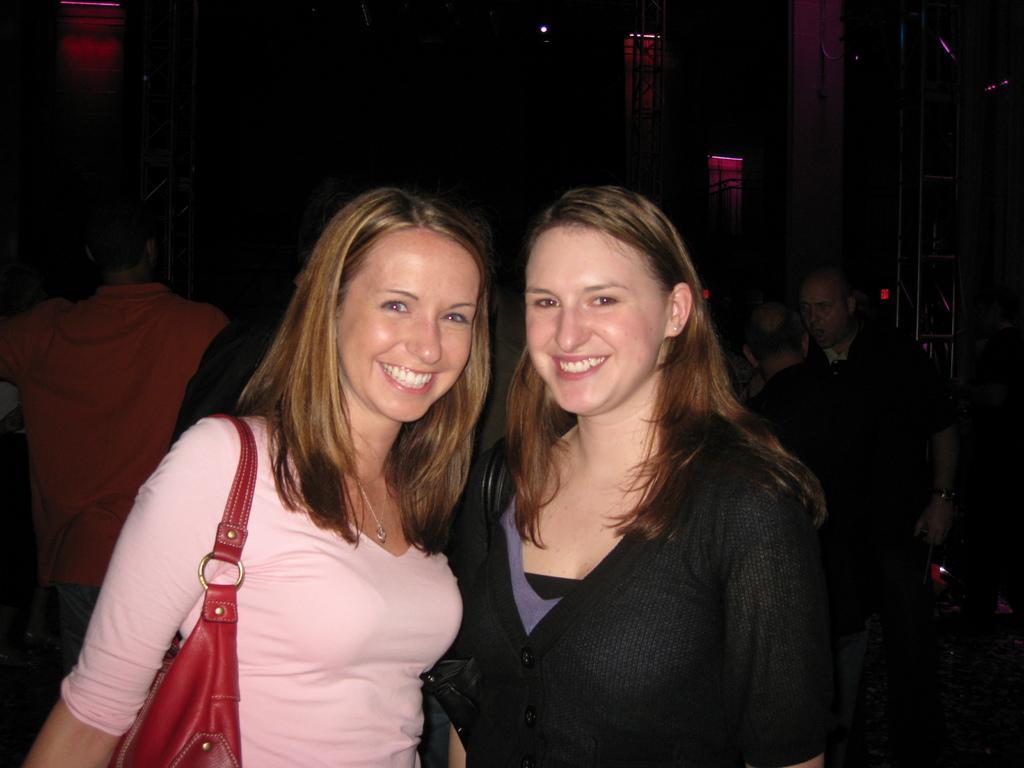Can you describe this image briefly? In the image we can see there are two women who are standing in front and at the back there are people standing. 